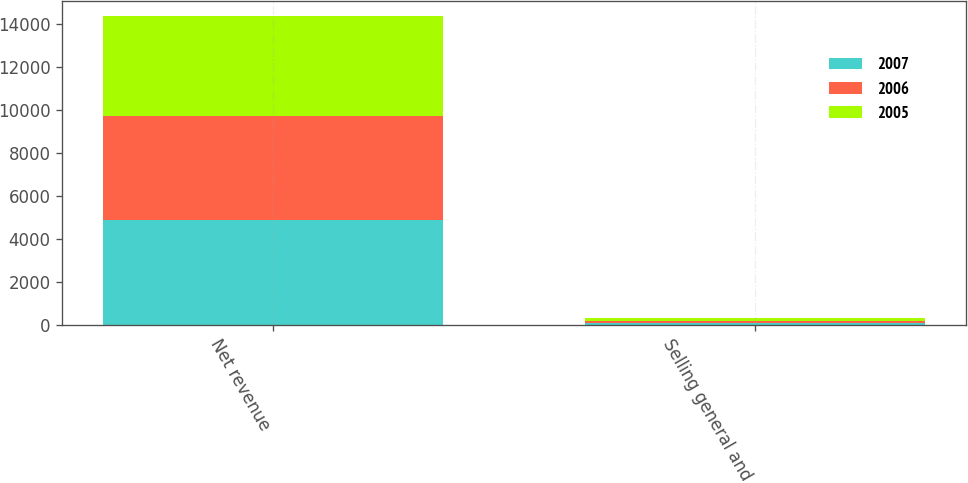Convert chart to OTSL. <chart><loc_0><loc_0><loc_500><loc_500><stacked_bar_chart><ecel><fcel>Net revenue<fcel>Selling general and<nl><fcel>2007<fcel>4874<fcel>91<nl><fcel>2006<fcel>4837<fcel>87<nl><fcel>2005<fcel>4633<fcel>143<nl></chart> 